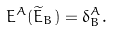Convert formula to latex. <formula><loc_0><loc_0><loc_500><loc_500>E ^ { A } ( \widetilde { E } _ { B } ) = \delta ^ { A } _ { B } .</formula> 